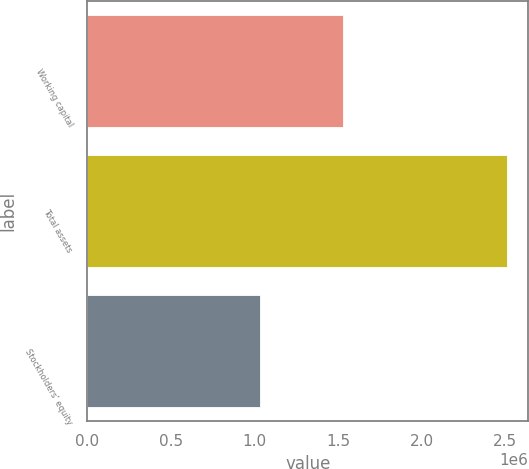Convert chart. <chart><loc_0><loc_0><loc_500><loc_500><bar_chart><fcel>Working capital<fcel>Total assets<fcel>Stockholders' equity<nl><fcel>1.52665e+06<fcel>2.51231e+06<fcel>1.03622e+06<nl></chart> 